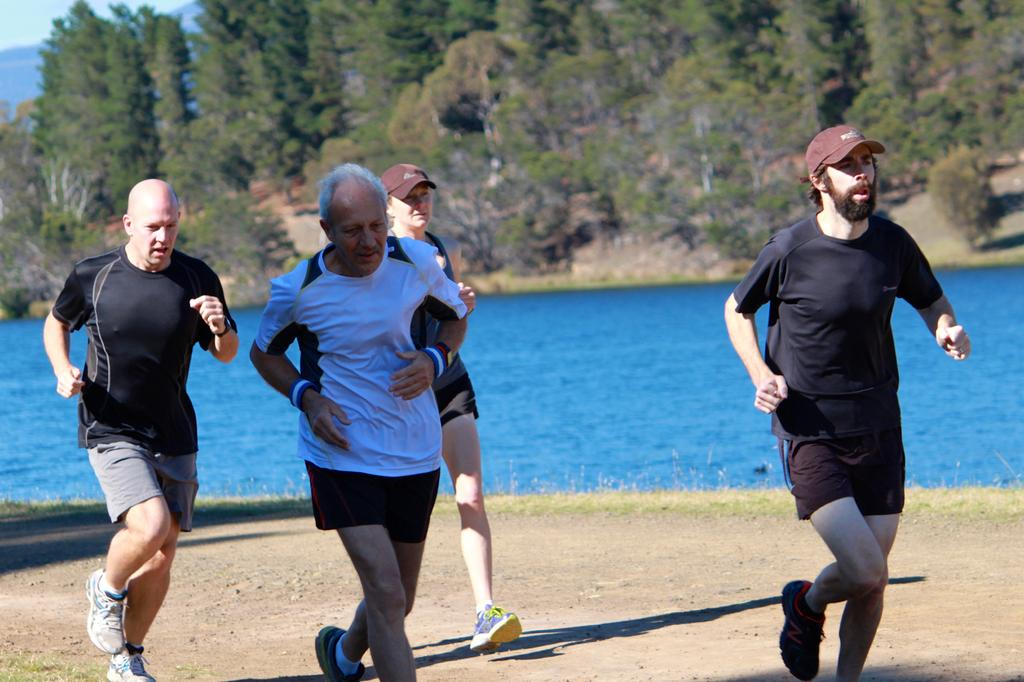What are the persons in the image doing? The persons in the image are running in the center of the image. What can be seen in the background of the image? There is water and trees visible in the background of the image. Where is the hydrant located in the image? There is no hydrant present in the image. What type of power source is visible in the image? There is no power source visible in the image. 